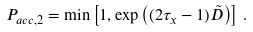Convert formula to latex. <formula><loc_0><loc_0><loc_500><loc_500>P _ { a c c , 2 } = \min \left [ 1 , \exp \left ( ( 2 \tau _ { x } - 1 ) \tilde { D } \right ) \right ] \, .</formula> 